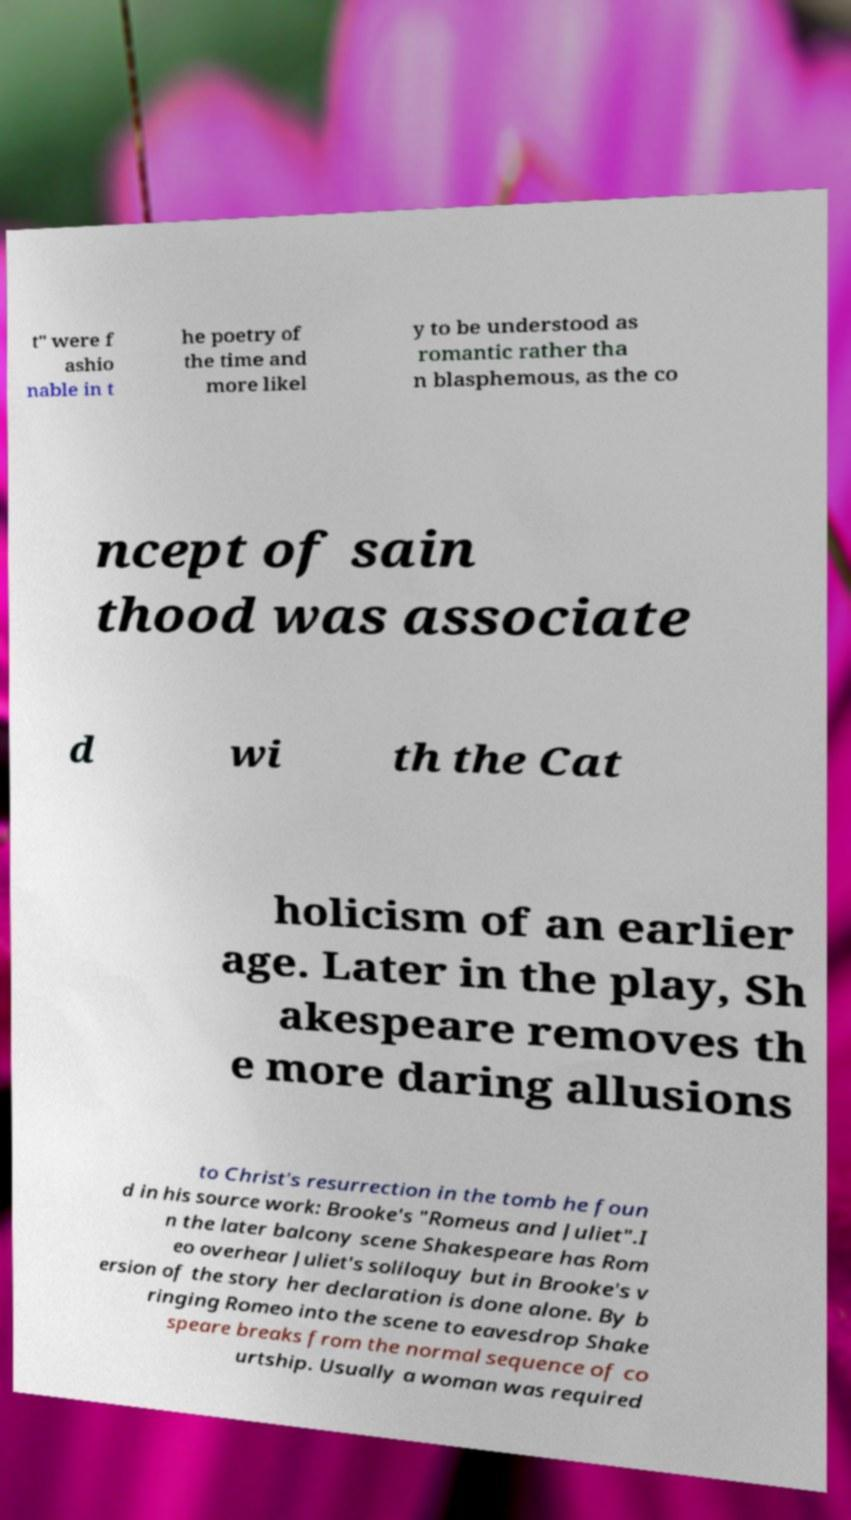For documentation purposes, I need the text within this image transcribed. Could you provide that? t" were f ashio nable in t he poetry of the time and more likel y to be understood as romantic rather tha n blasphemous, as the co ncept of sain thood was associate d wi th the Cat holicism of an earlier age. Later in the play, Sh akespeare removes th e more daring allusions to Christ's resurrection in the tomb he foun d in his source work: Brooke's "Romeus and Juliet".I n the later balcony scene Shakespeare has Rom eo overhear Juliet's soliloquy but in Brooke's v ersion of the story her declaration is done alone. By b ringing Romeo into the scene to eavesdrop Shake speare breaks from the normal sequence of co urtship. Usually a woman was required 